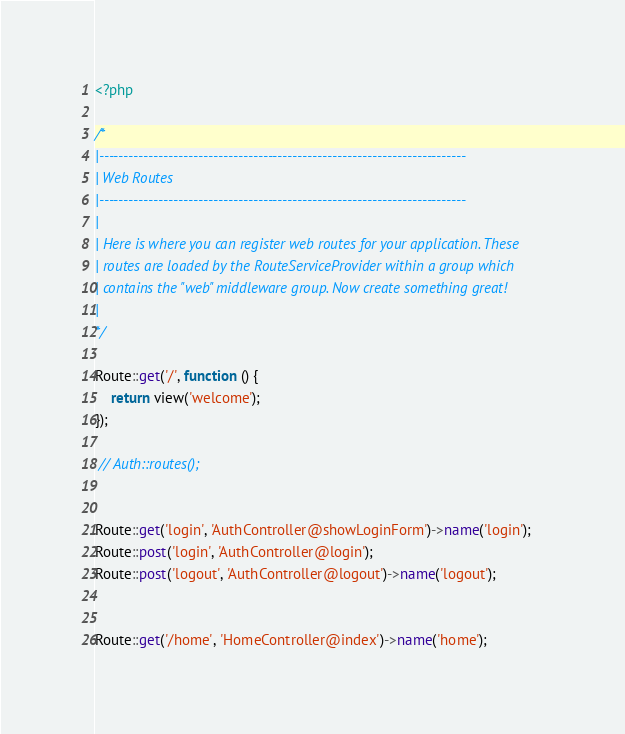Convert code to text. <code><loc_0><loc_0><loc_500><loc_500><_PHP_><?php

/*
|--------------------------------------------------------------------------
| Web Routes
|--------------------------------------------------------------------------
|
| Here is where you can register web routes for your application. These
| routes are loaded by the RouteServiceProvider within a group which
| contains the "web" middleware group. Now create something great!
|
*/

Route::get('/', function () {
    return view('welcome');
});

 // Auth::routes();


Route::get('login', 'AuthController@showLoginForm')->name('login');
Route::post('login', 'AuthController@login');
Route::post('logout', 'AuthController@logout')->name('logout');


Route::get('/home', 'HomeController@index')->name('home');
</code> 